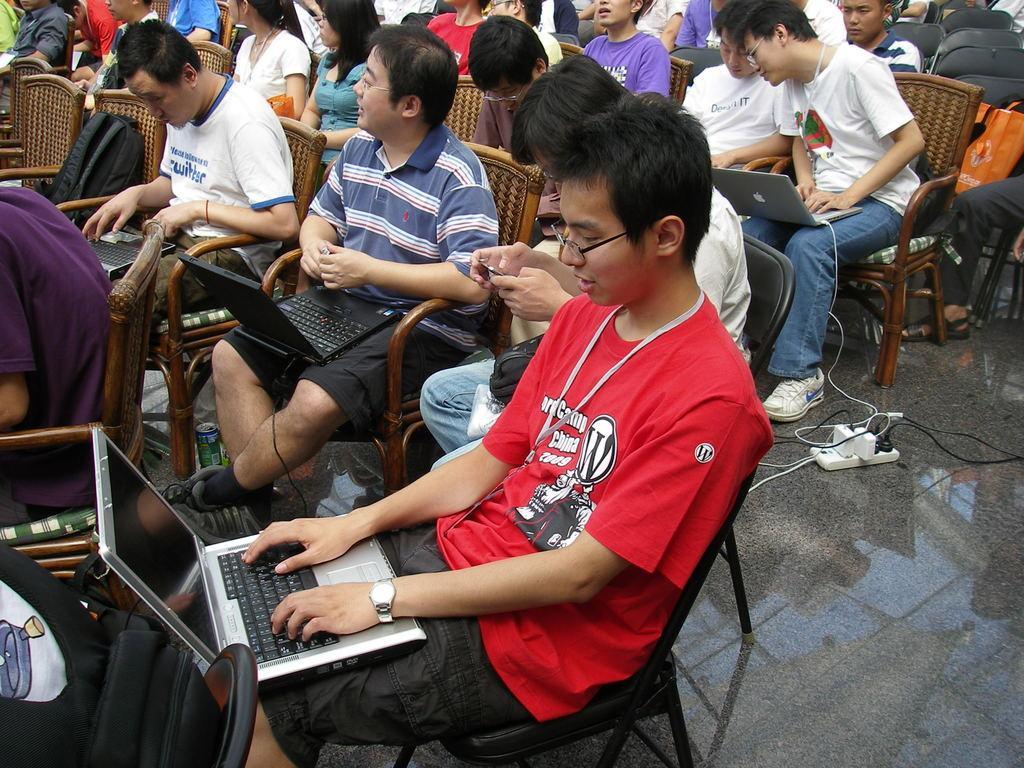In one or two sentences, can you explain what this image depicts? In this picture I can see few people seated on the chairs and few of them working on the laptops and I can see a extension switchboard on the floor. 